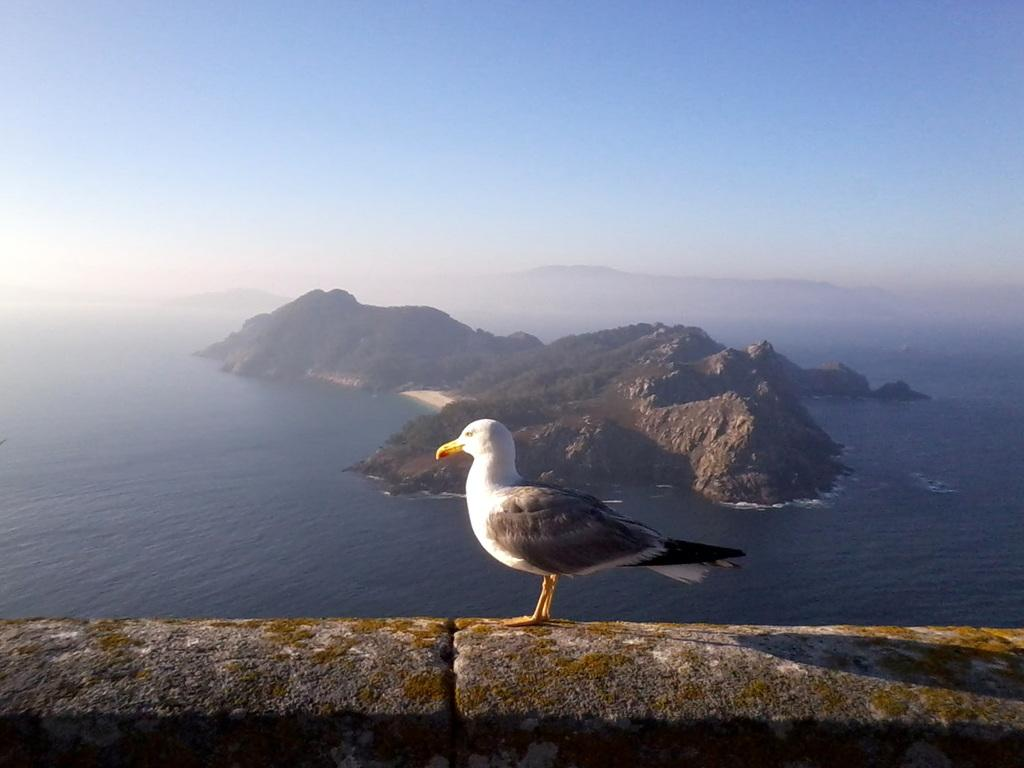What type of animal can be seen on the ground in the image? There is a bird on the ground in the image. What can be seen in the distance behind the bird? There is water and mountains visible in the background of the image. What is the condition of the sky in the image? The sky is cloudy in the background of the image. What type of loaf is being baked in the image? There is no loaf present in the image; it features a bird on the ground with water, mountains, and a cloudy sky in the background. 